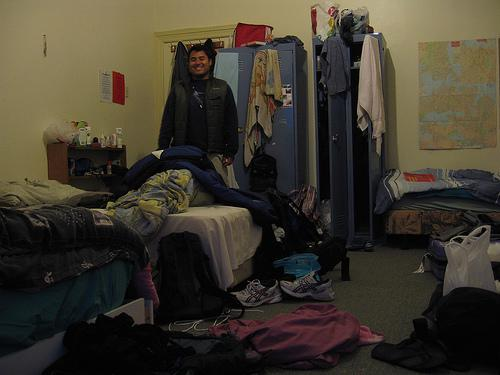Question: what color are the lockers?
Choices:
A. Blue.
B. Green.
C. Grey.
D. Red.
Answer with the letter. Answer: A Question: who is standing?
Choices:
A. The bear.
B. The woman.
C. The girl.
D. The man.
Answer with the letter. Answer: D Question: why is it so bright?
Choices:
A. Lights on.
B. Sun is shining.
C. The blinds are open.
D. It's day break.
Answer with the letter. Answer: A 